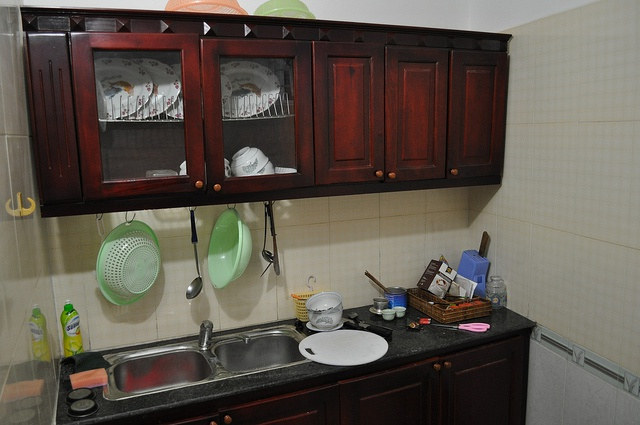Describe the objects in this image and their specific colors. I can see sink in darkgray, maroon, gray, and black tones, sink in darkgray, gray, and black tones, bowl in darkgray and green tones, bottle in darkgray, olive, and gray tones, and bowl in darkgray, gray, and lightgray tones in this image. 